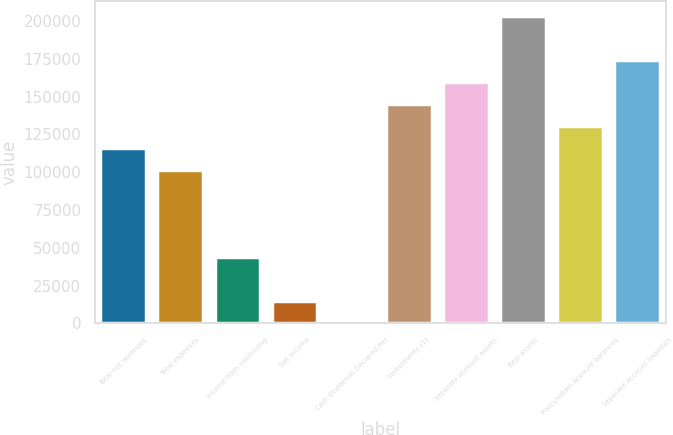Convert chart to OTSL. <chart><loc_0><loc_0><loc_500><loc_500><bar_chart><fcel>Total net revenues<fcel>Total expenses<fcel>Income from continuing<fcel>Net income<fcel>Cash Dividends Declared Per<fcel>Investments (1)<fcel>Separate account assets<fcel>Total assets<fcel>Policyholder account balances<fcel>Separate account liabilities<nl><fcel>116208<fcel>101682<fcel>43579.5<fcel>14528.2<fcel>2.59<fcel>145259<fcel>159785<fcel>203362<fcel>130733<fcel>174310<nl></chart> 